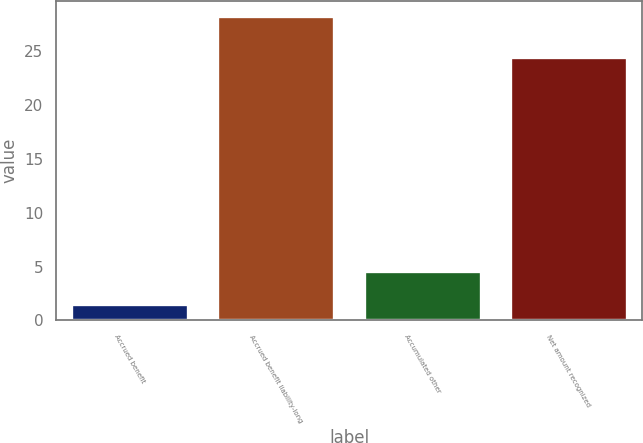Convert chart. <chart><loc_0><loc_0><loc_500><loc_500><bar_chart><fcel>Accrued benefit<fcel>Accrued benefit liability-long<fcel>Accumulated other<fcel>Net amount recognized<nl><fcel>1.5<fcel>28.2<fcel>4.6<fcel>24.4<nl></chart> 